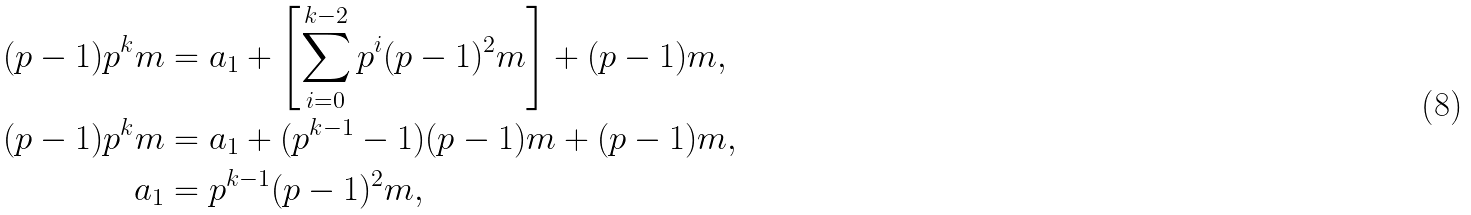Convert formula to latex. <formula><loc_0><loc_0><loc_500><loc_500>( p - 1 ) p ^ { k } m & = a _ { 1 } + \left [ \sum _ { i = 0 } ^ { k - 2 } p ^ { i } ( p - 1 ) ^ { 2 } m \right ] + ( p - 1 ) m , \\ ( p - 1 ) p ^ { k } m & = a _ { 1 } + ( p ^ { k - 1 } - 1 ) ( p - 1 ) m + ( p - 1 ) m , \\ a _ { 1 } & = p ^ { k - 1 } ( p - 1 ) ^ { 2 } m ,</formula> 